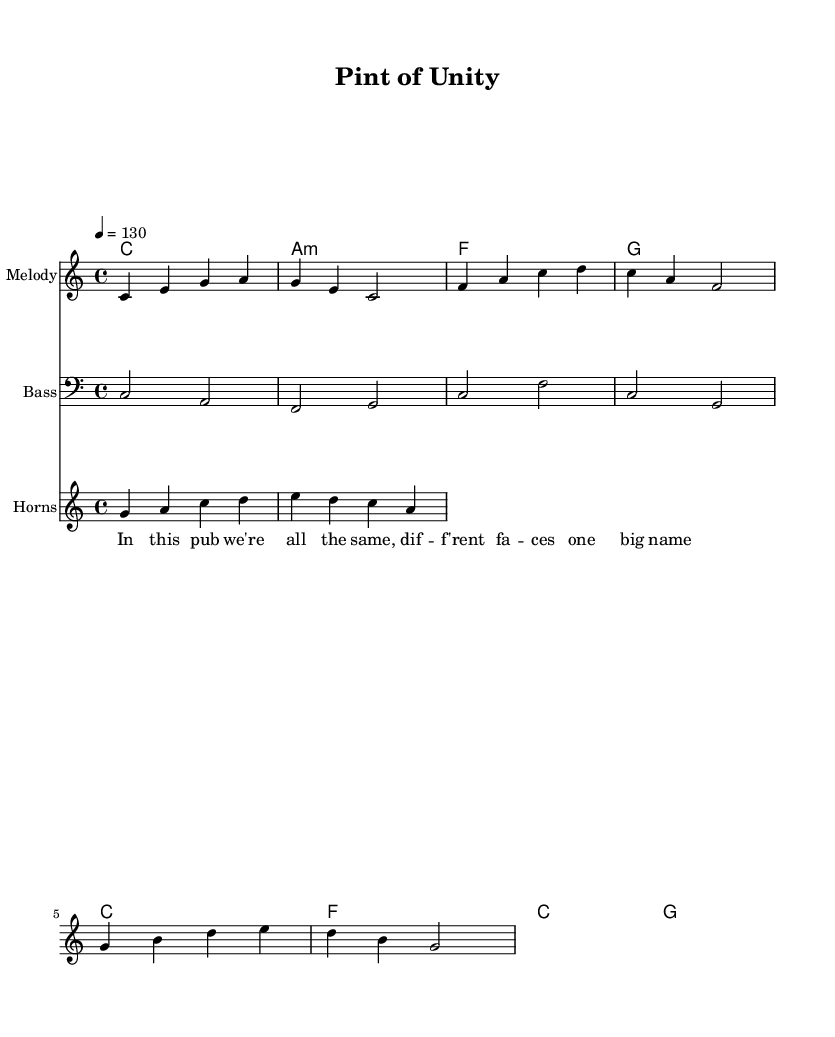What is the key signature of this music? The key signature is indicated at the beginning where it states "c \major," meaning there are no sharps or flats.
Answer: C major What is the time signature of this music? The time signature is found at the beginning, represented as "4/4," indicating four beats per measure.
Answer: 4/4 What is the tempo marking for this piece? The tempo is designated by "4 = 130," meaning there are 130 beats per minute, typically in quarter note values.
Answer: 130 How many measures are in the melody? Counting the measures in the melody staff, there are 6 measures in total presented as 4/4 time.
Answer: 6 What chord follows A minor in the chord progression? Reviewing the chord progression, after "a:m," the next chord is "f," which is the sequence listed in the chordNames.
Answer: F What kind of ensemble is featured in this piece? The score has multiple staves indicating a band configuration, including melody, bass, and horns, characteristic of reggae and ska genres focused on collective play.
Answer: Band What is the main theme of the lyrics? Analyzing the lyrics provided, they refer to camaraderie and unity among different people in a pub setting, celebrating togetherness in a casual drinking atmosphere.
Answer: Unity 